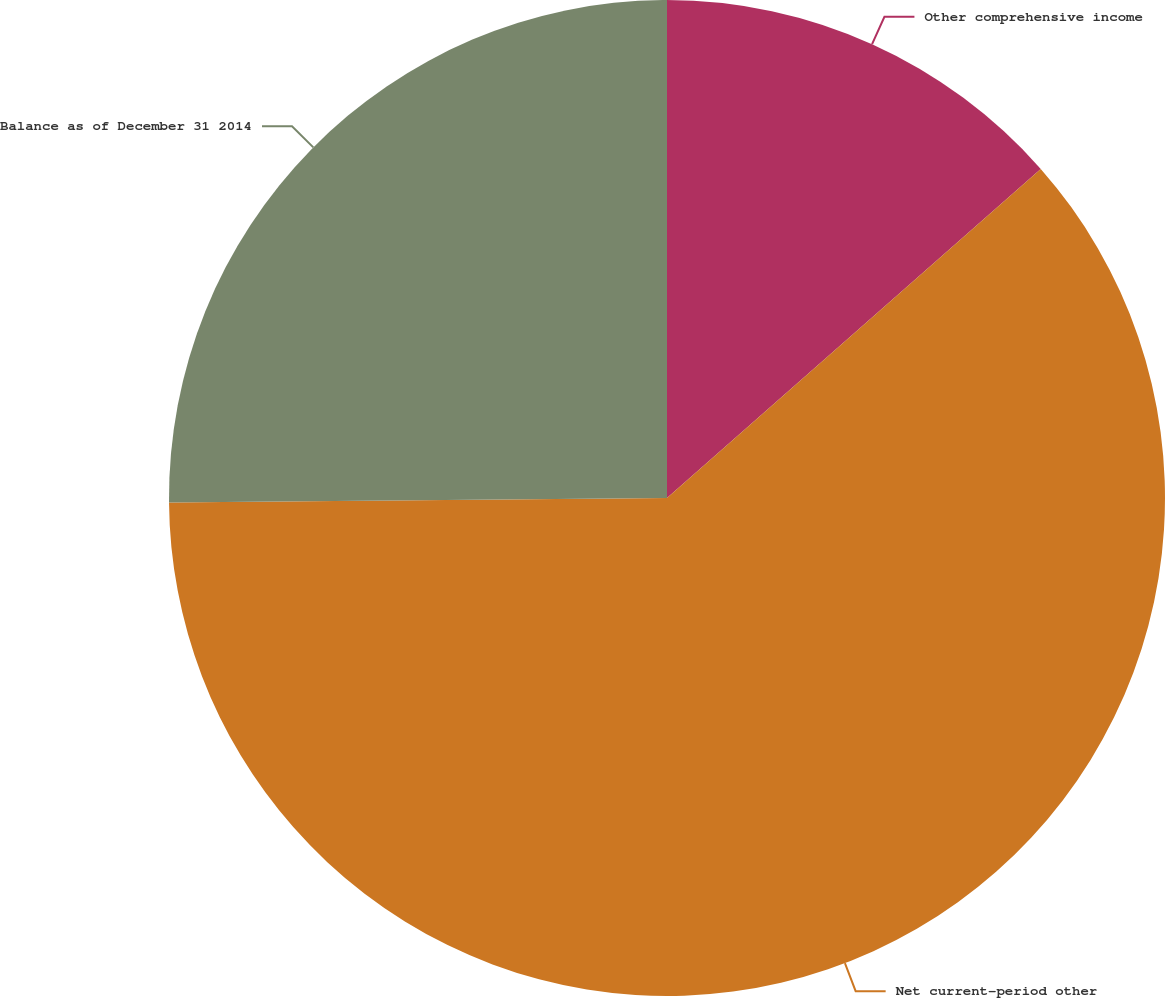Convert chart to OTSL. <chart><loc_0><loc_0><loc_500><loc_500><pie_chart><fcel>Other comprehensive income<fcel>Net current-period other<fcel>Balance as of December 31 2014<nl><fcel>13.51%<fcel>61.35%<fcel>25.14%<nl></chart> 